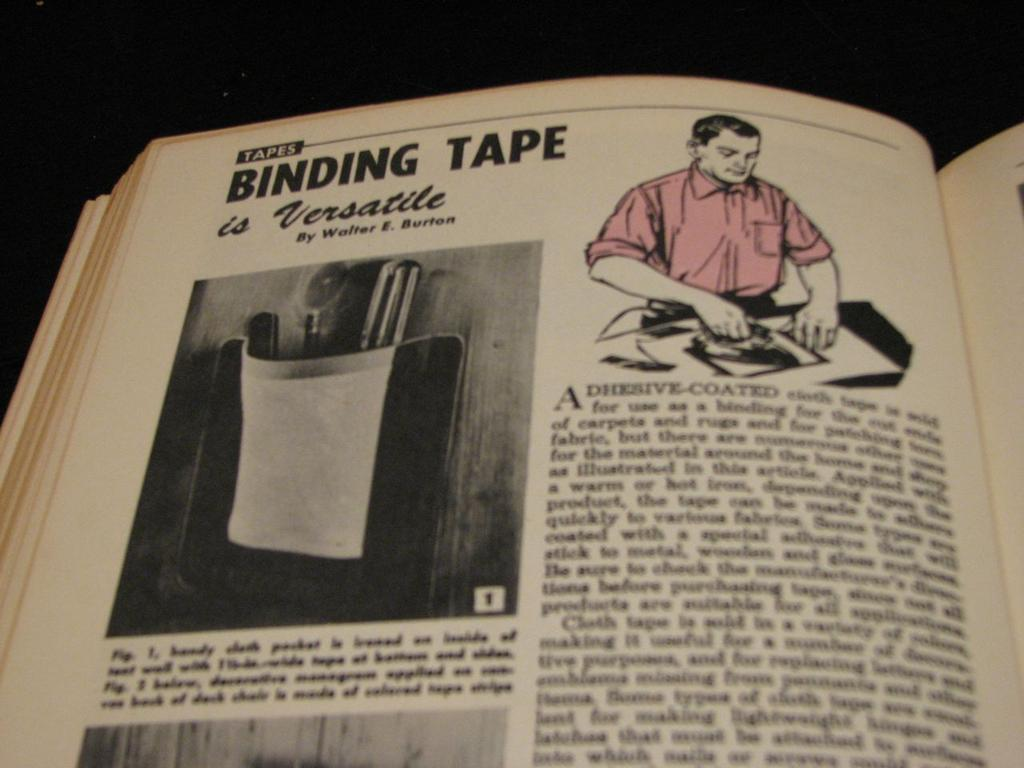<image>
Create a compact narrative representing the image presented. A page open in the book discusses how versatile binding tape is. 